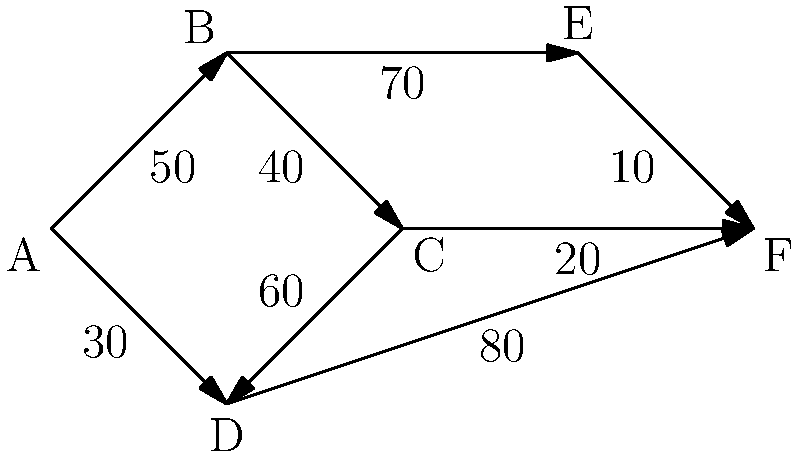Given the weighted graph representing the network connectivity between global team members, what is the minimum total latency (in milliseconds) required to establish a connection path that includes all team members? To find the minimum total latency that includes all team members, we need to find the minimum spanning tree (MST) of the given graph. We can use Kruskal's algorithm to solve this problem:

1. Sort all edges by weight in ascending order:
   E-F (10), C-F (20), A-D (30), B-C (40), A-B (50), C-D (60), B-E (70), D-F (80)

2. Start with an empty set of edges and add edges in order, skipping those that would create a cycle:
   - Add E-F (10)
   - Add C-F (20)
   - Add A-D (30)
   - Add B-C (40)
   - Add A-B (50) (skipped, as it would create a cycle)
   - Add C-D (60) (skipped, as it would create a cycle)
   - Add B-E (70)

3. The MST is now complete with 5 edges (the number of vertices minus 1).

4. Sum the weights of the selected edges:
   10 + 20 + 30 + 40 + 70 = 170

Therefore, the minimum total latency required to establish a connection path that includes all team members is 170 milliseconds.
Answer: 170 ms 